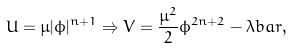<formula> <loc_0><loc_0><loc_500><loc_500>U = \mu | \phi | ^ { n + 1 } \Rightarrow V = \frac { \mu ^ { 2 } } 2 \phi ^ { 2 n + 2 } - \lambda b a r ,</formula> 